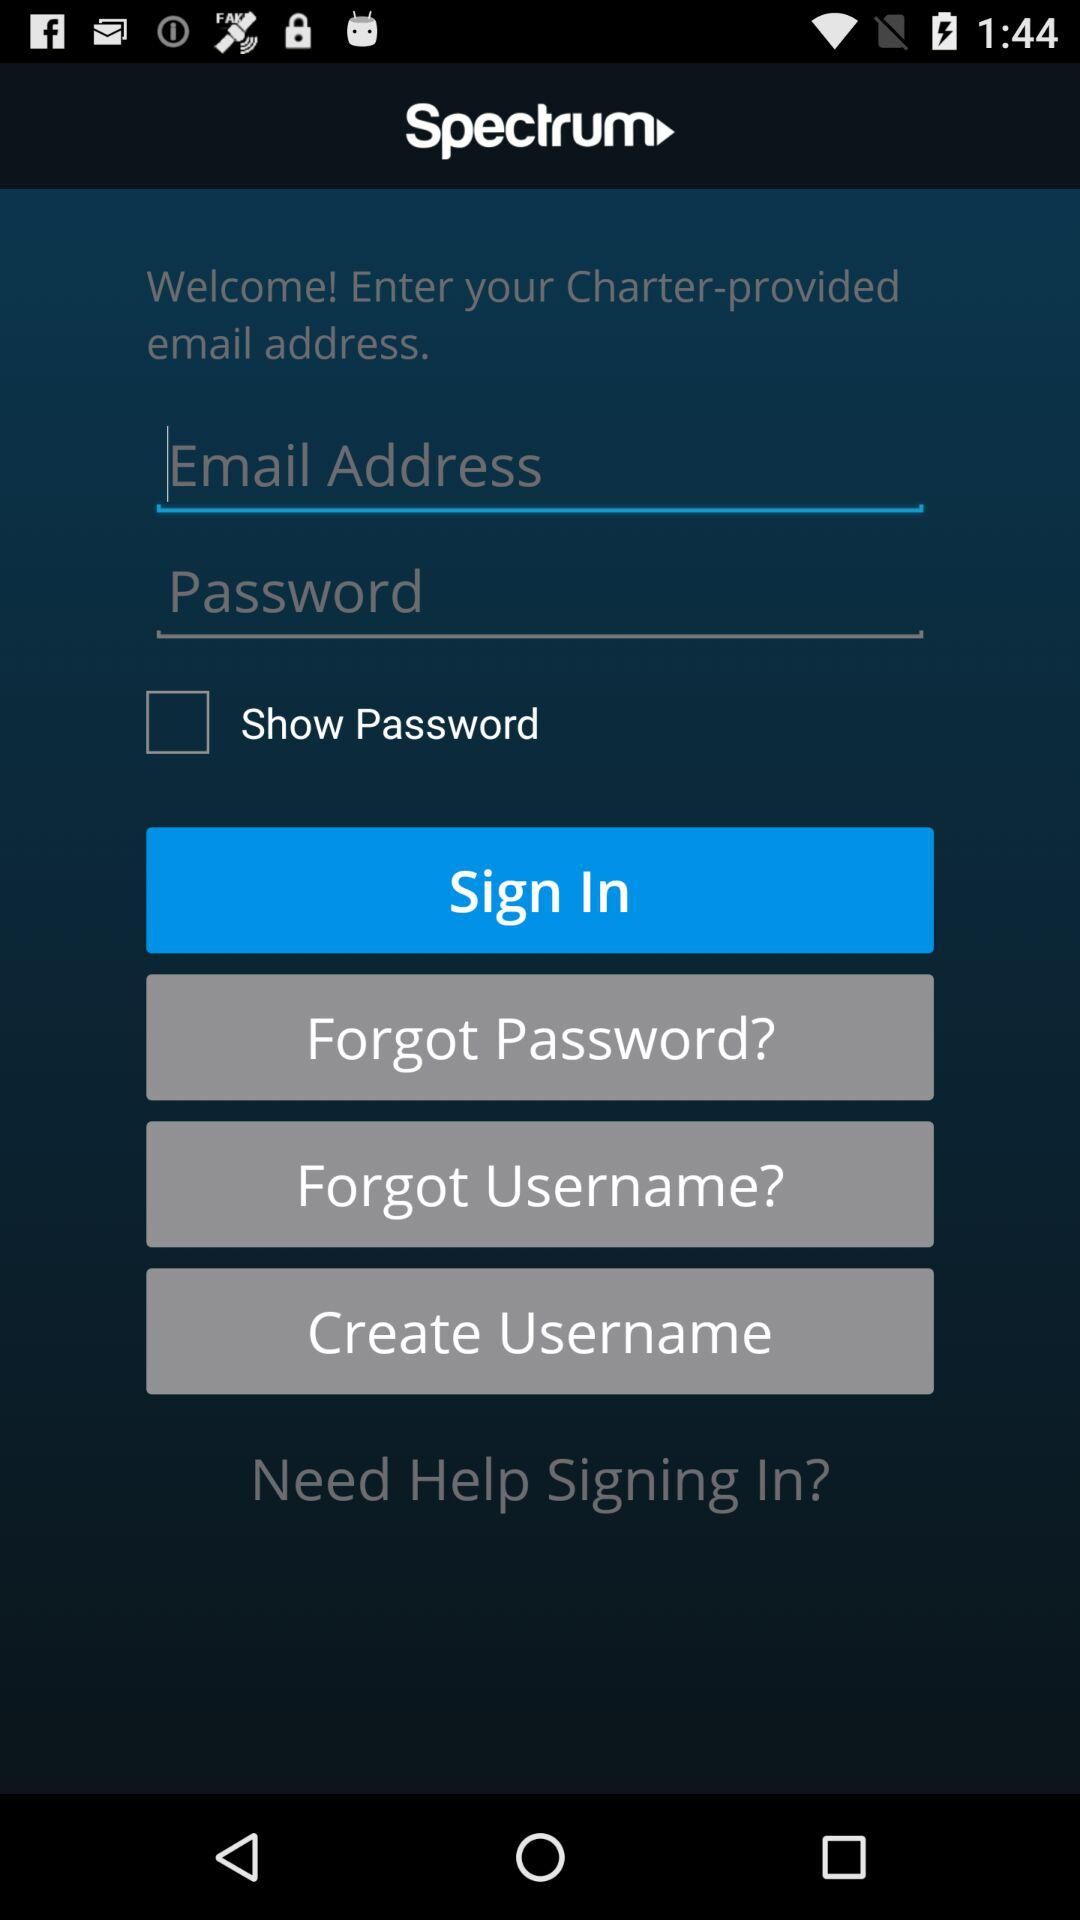What is the name of the application? The name of the application is "Spectrum". 